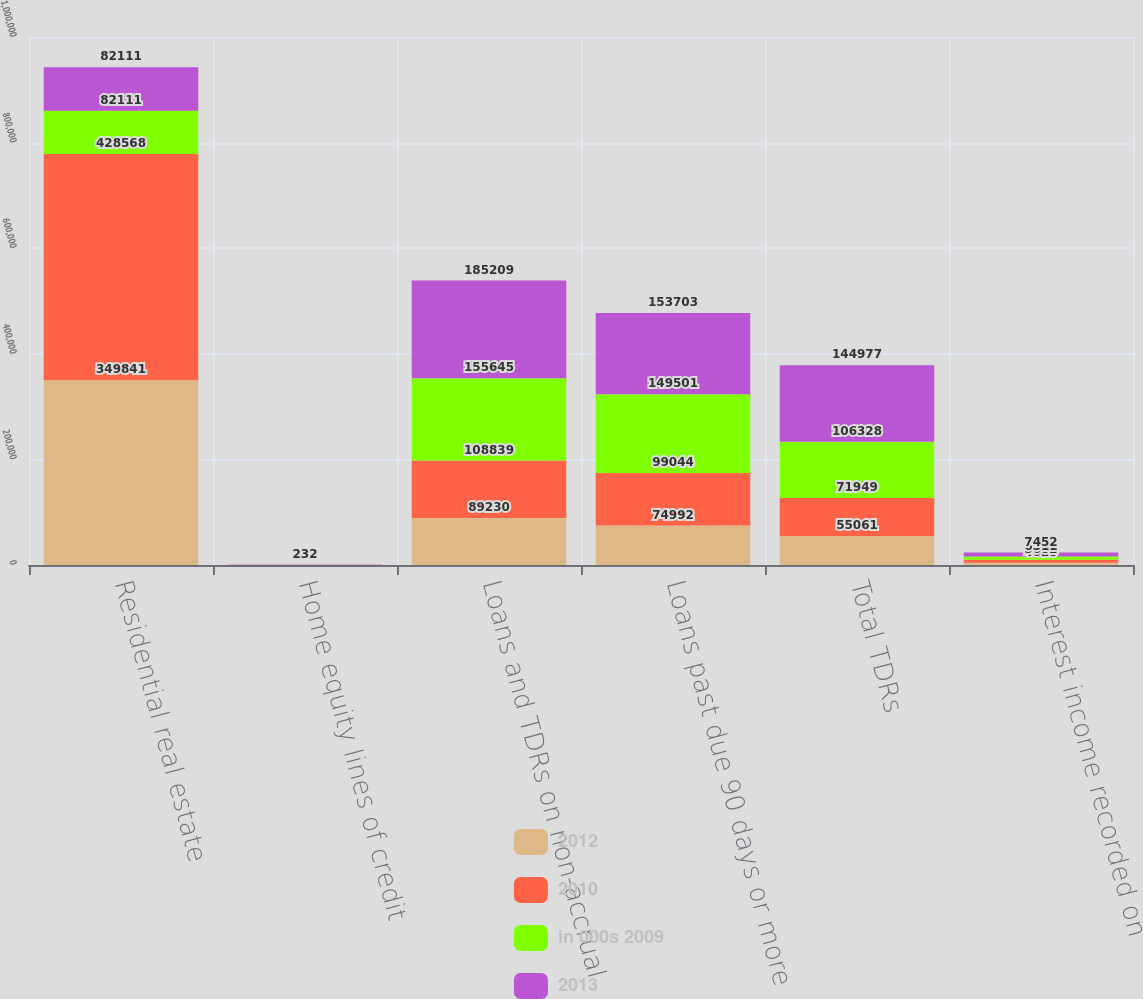<chart> <loc_0><loc_0><loc_500><loc_500><stacked_bar_chart><ecel><fcel>Residential real estate<fcel>Home equity lines of credit<fcel>Loans and TDRs on non-accrual<fcel>Loans past due 90 days or more<fcel>Total TDRs<fcel>Interest income recorded on<nl><fcel>2012<fcel>349841<fcel>170<fcel>89230<fcel>74992<fcel>55061<fcel>4025<nl><fcel>2010<fcel>428568<fcel>174<fcel>108839<fcel>99044<fcel>71949<fcel>5682<nl><fcel>in 000s 2009<fcel>82111<fcel>183<fcel>155645<fcel>149501<fcel>106328<fcel>6311<nl><fcel>2013<fcel>82111<fcel>232<fcel>185209<fcel>153703<fcel>144977<fcel>7452<nl></chart> 